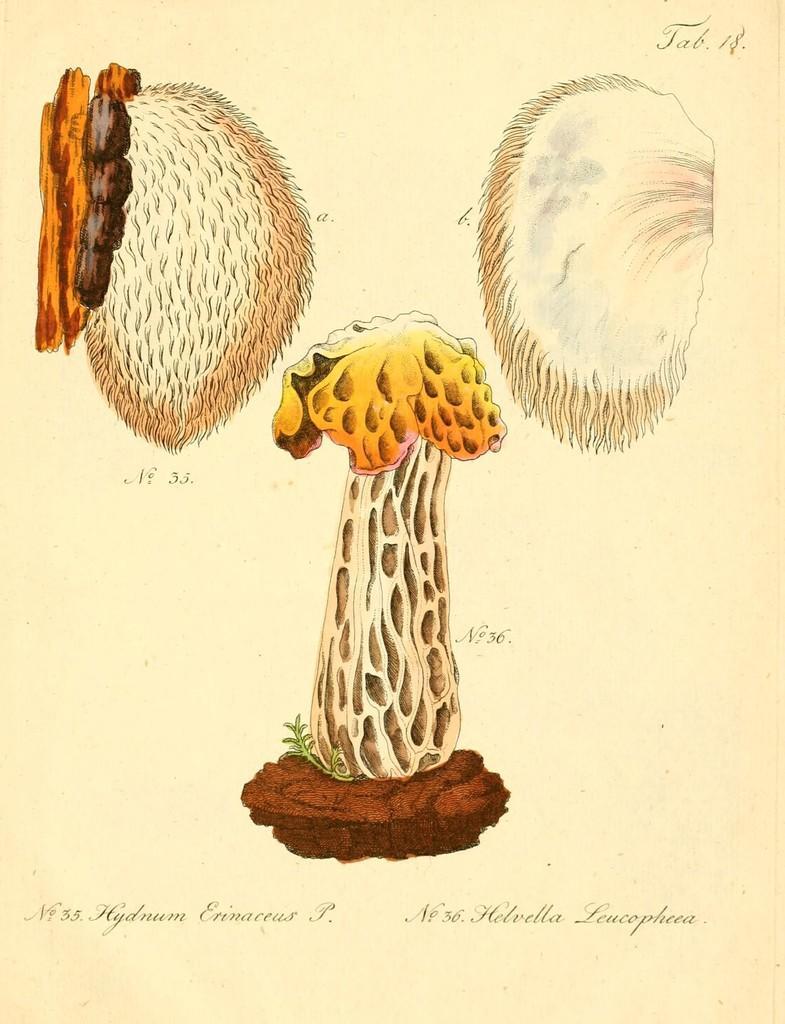How would you summarize this image in a sentence or two? It is a poster. In this image there is a depiction of a mushroom and there are some objects. There is some text on this image. 